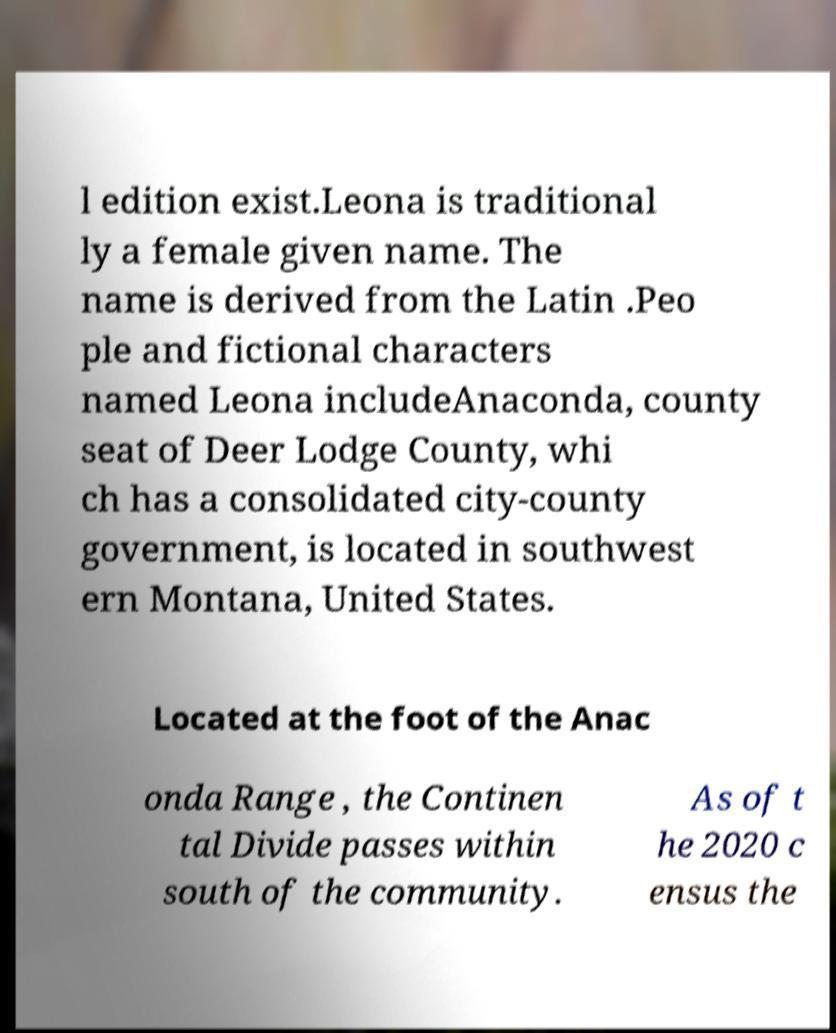I need the written content from this picture converted into text. Can you do that? l edition exist.Leona is traditional ly a female given name. The name is derived from the Latin .Peo ple and fictional characters named Leona includeAnaconda, county seat of Deer Lodge County, whi ch has a consolidated city-county government, is located in southwest ern Montana, United States. Located at the foot of the Anac onda Range , the Continen tal Divide passes within south of the community. As of t he 2020 c ensus the 